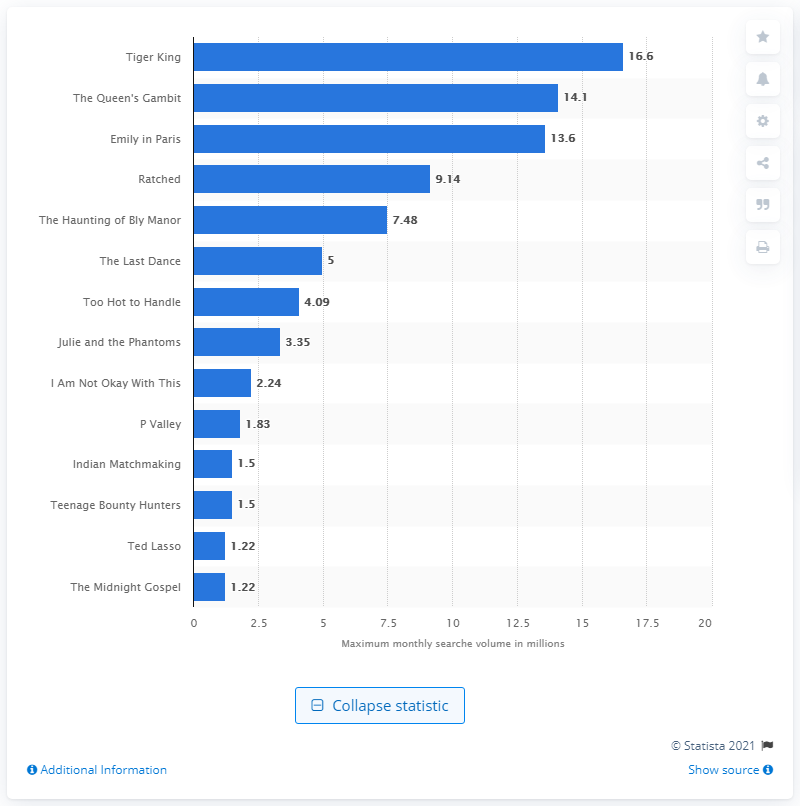Highlight a few significant elements in this photo. According to the search volume worldwide in 2020, the TV show with the highest search volume was "Tiger King. The maximum monthly search volume for Tiger King was 16.6.. The maximum monthly search volume for The Queen's Gambit was 14.1. 